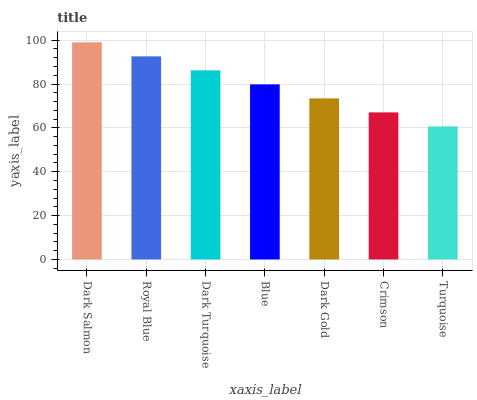Is Royal Blue the minimum?
Answer yes or no. No. Is Royal Blue the maximum?
Answer yes or no. No. Is Dark Salmon greater than Royal Blue?
Answer yes or no. Yes. Is Royal Blue less than Dark Salmon?
Answer yes or no. Yes. Is Royal Blue greater than Dark Salmon?
Answer yes or no. No. Is Dark Salmon less than Royal Blue?
Answer yes or no. No. Is Blue the high median?
Answer yes or no. Yes. Is Blue the low median?
Answer yes or no. Yes. Is Crimson the high median?
Answer yes or no. No. Is Dark Salmon the low median?
Answer yes or no. No. 